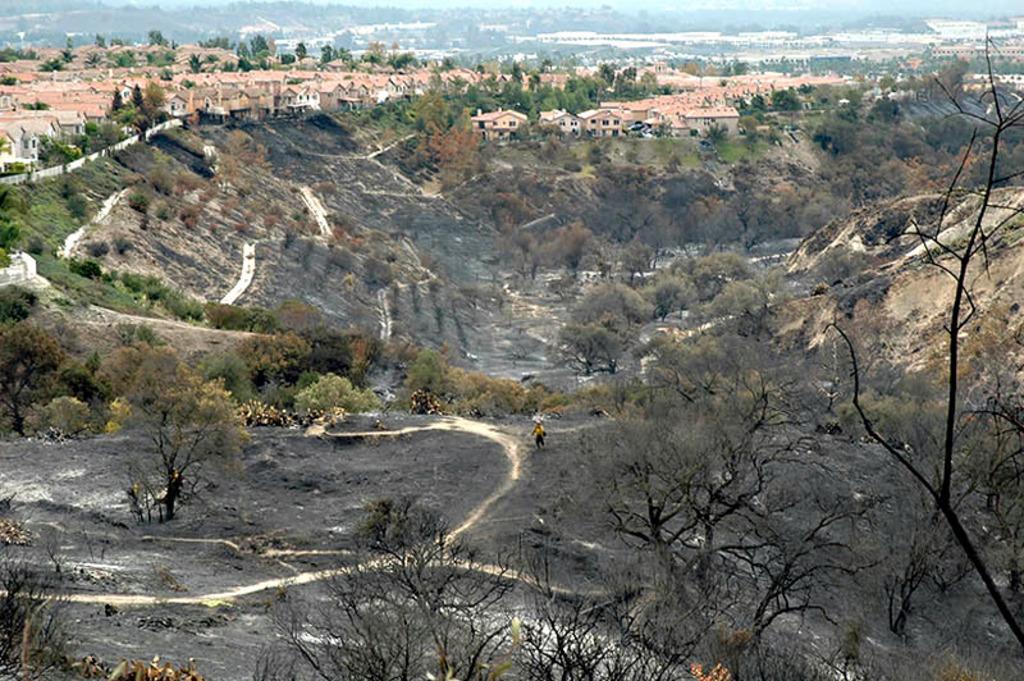Could you give a brief overview of what you see in this image? In this image there are buildings. At the bottom there are trees and roads. In the background there are hills and sky. 